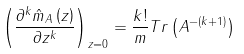Convert formula to latex. <formula><loc_0><loc_0><loc_500><loc_500>\left ( \frac { \partial ^ { k } \hat { m } _ { A } \left ( z \right ) } { \partial z ^ { k } } \right ) _ { z = 0 } = \frac { k ! } { m } T r \left ( A ^ { - \left ( k + 1 \right ) } \right )</formula> 